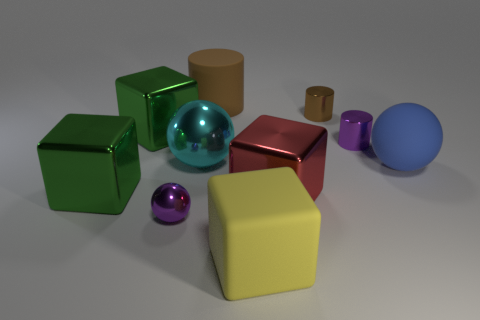Are there any shiny things that have the same color as the big cylinder?
Give a very brief answer. Yes. There is a cube that is made of the same material as the large brown cylinder; what is its size?
Give a very brief answer. Large. Is there anything else that is the same color as the rubber sphere?
Your answer should be very brief. No. What color is the big metal thing that is behind the small purple cylinder?
Provide a short and direct response. Green. There is a big red thing right of the green metal object that is in front of the big cyan metallic ball; is there a metallic sphere that is in front of it?
Provide a short and direct response. Yes. Is the number of green metal cubes that are behind the blue thing greater than the number of large purple metal cylinders?
Ensure brevity in your answer.  Yes. There is a big thing behind the brown shiny object; does it have the same shape as the small brown metallic object?
Provide a succinct answer. Yes. How many objects are big purple rubber balls or small purple metal things that are to the right of the large yellow rubber thing?
Offer a very short reply. 1. What is the size of the thing that is behind the cyan thing and right of the tiny brown metallic cylinder?
Ensure brevity in your answer.  Small. Is the number of rubber cubes that are behind the big rubber cylinder greater than the number of large matte cylinders to the left of the red thing?
Your answer should be very brief. No. 